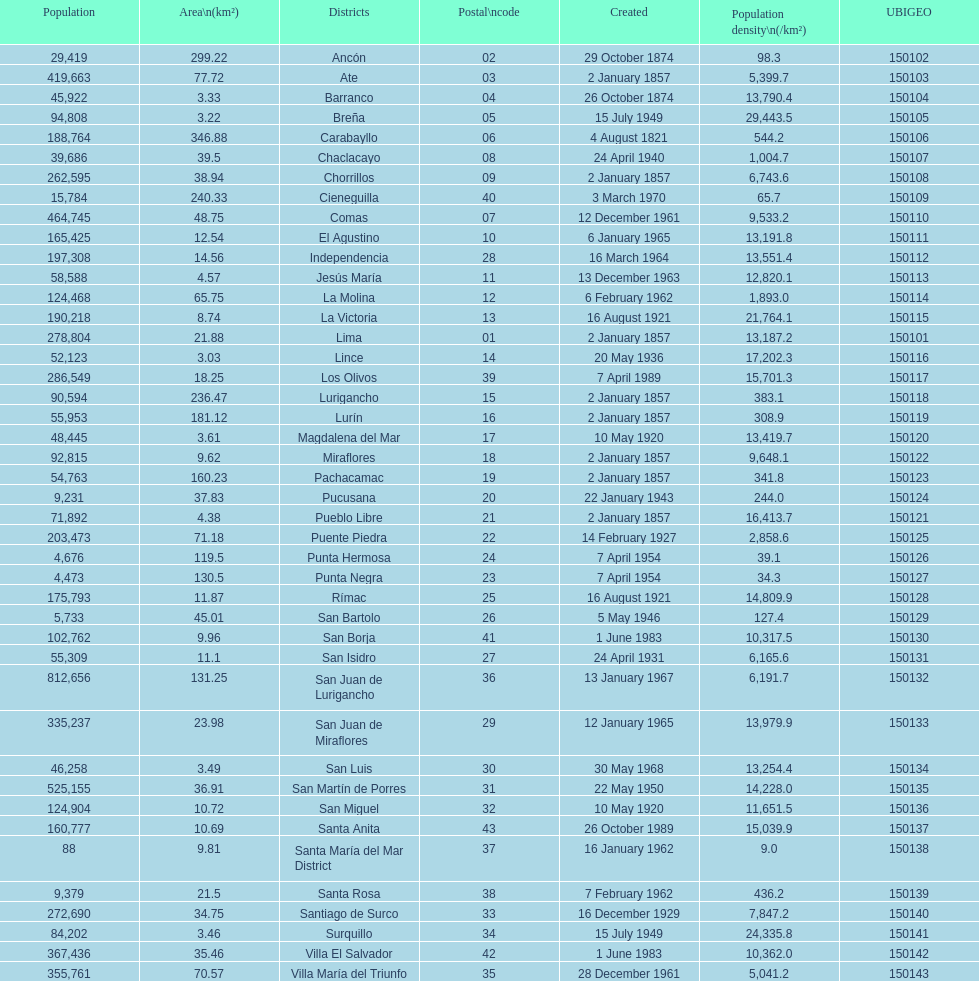Which is the largest district in terms of population? San Juan de Lurigancho. 